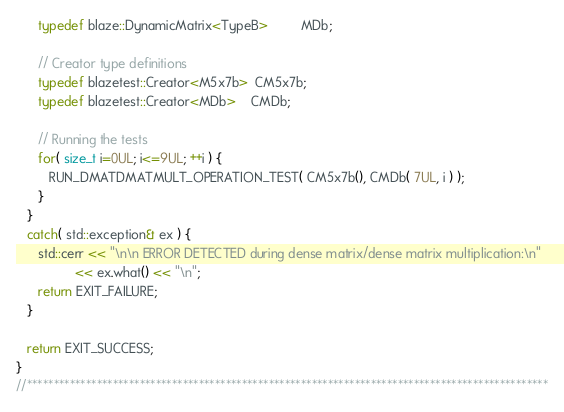Convert code to text. <code><loc_0><loc_0><loc_500><loc_500><_C++_>      typedef blaze::DynamicMatrix<TypeB>         MDb;

      // Creator type definitions
      typedef blazetest::Creator<M5x7b>  CM5x7b;
      typedef blazetest::Creator<MDb>    CMDb;

      // Running the tests
      for( size_t i=0UL; i<=9UL; ++i ) {
         RUN_DMATDMATMULT_OPERATION_TEST( CM5x7b(), CMDb( 7UL, i ) );
      }
   }
   catch( std::exception& ex ) {
      std::cerr << "\n\n ERROR DETECTED during dense matrix/dense matrix multiplication:\n"
                << ex.what() << "\n";
      return EXIT_FAILURE;
   }

   return EXIT_SUCCESS;
}
//*************************************************************************************************
</code> 